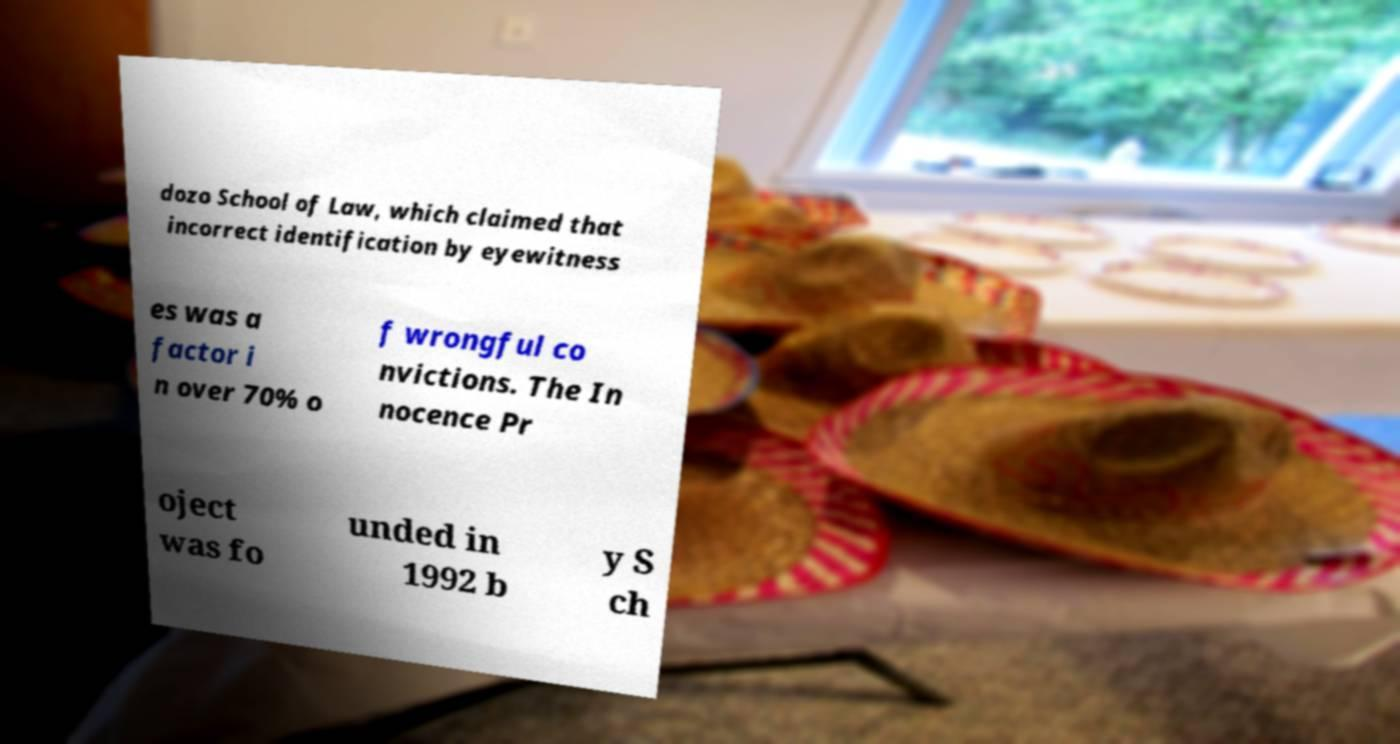There's text embedded in this image that I need extracted. Can you transcribe it verbatim? dozo School of Law, which claimed that incorrect identification by eyewitness es was a factor i n over 70% o f wrongful co nvictions. The In nocence Pr oject was fo unded in 1992 b y S ch 